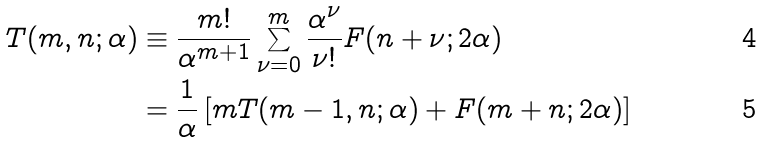<formula> <loc_0><loc_0><loc_500><loc_500>T ( m , n ; \alpha ) & \equiv \frac { m ! } { \alpha ^ { m + 1 } } \sum ^ { m } _ { \nu = 0 } \frac { \alpha ^ { \nu } } { \nu ! } F ( n + \nu ; 2 \alpha ) \\ & = \frac { 1 } { \alpha } \left [ m T ( m - 1 , n ; \alpha ) + F ( m + n ; 2 \alpha ) \right ]</formula> 